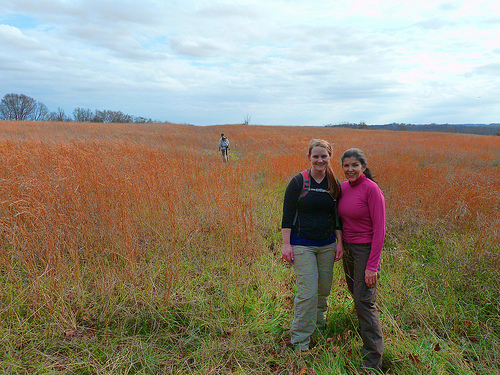<image>
Is the head on the grass? No. The head is not positioned on the grass. They may be near each other, but the head is not supported by or resting on top of the grass. Where is the girl in relation to the man? Is it in front of the man? Yes. The girl is positioned in front of the man, appearing closer to the camera viewpoint. 